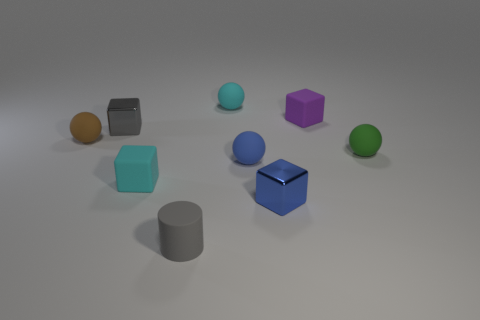Are there any other things that are the same shape as the tiny gray rubber thing?
Your answer should be compact. No. What is the material of the small ball that is both to the left of the purple matte object and in front of the brown ball?
Your response must be concise. Rubber. What number of matte things are in front of the purple rubber thing?
Give a very brief answer. 5. There is a tiny cube that is the same material as the purple object; what color is it?
Your answer should be compact. Cyan. Does the green rubber object have the same shape as the tiny brown object?
Provide a short and direct response. Yes. How many small things are on the left side of the small purple rubber block and on the right side of the brown rubber thing?
Give a very brief answer. 6. What number of rubber things are either gray things or things?
Provide a short and direct response. 7. There is a cube that is the same color as the tiny matte cylinder; what is its material?
Your answer should be compact. Metal. Are there any tiny metal objects to the left of the cyan matte thing that is in front of the cyan object that is behind the purple thing?
Ensure brevity in your answer.  Yes. Are the small gray object that is on the left side of the gray rubber cylinder and the tiny cyan thing in front of the tiny brown ball made of the same material?
Provide a short and direct response. No. 